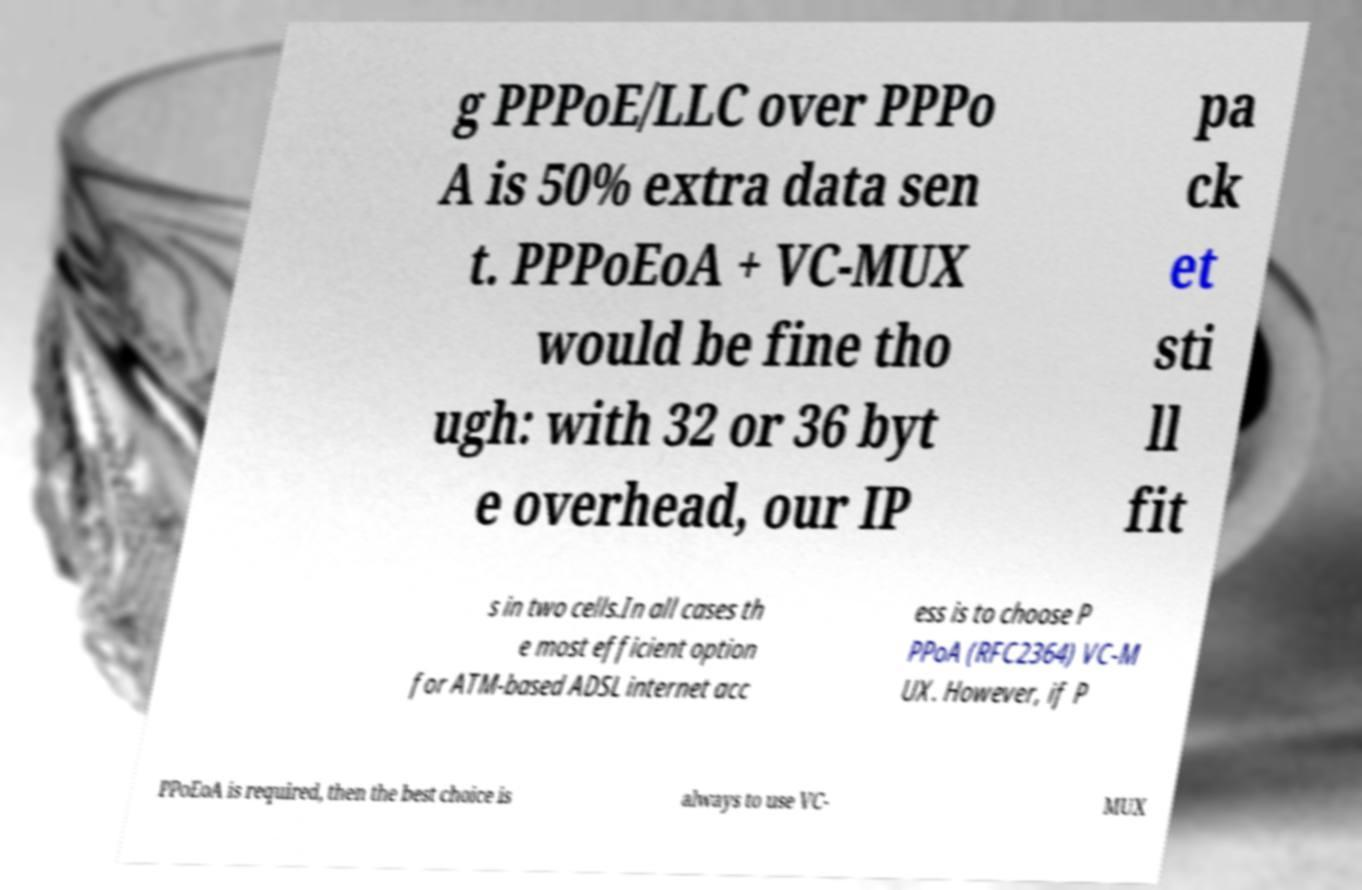Can you read and provide the text displayed in the image?This photo seems to have some interesting text. Can you extract and type it out for me? g PPPoE/LLC over PPPo A is 50% extra data sen t. PPPoEoA + VC-MUX would be fine tho ugh: with 32 or 36 byt e overhead, our IP pa ck et sti ll fit s in two cells.In all cases th e most efficient option for ATM-based ADSL internet acc ess is to choose P PPoA (RFC2364) VC-M UX. However, if P PPoEoA is required, then the best choice is always to use VC- MUX 